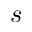Convert formula to latex. <formula><loc_0><loc_0><loc_500><loc_500>s</formula> 